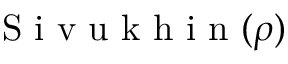<formula> <loc_0><loc_0><loc_500><loc_500>S i v u k h i n ( \rho )</formula> 